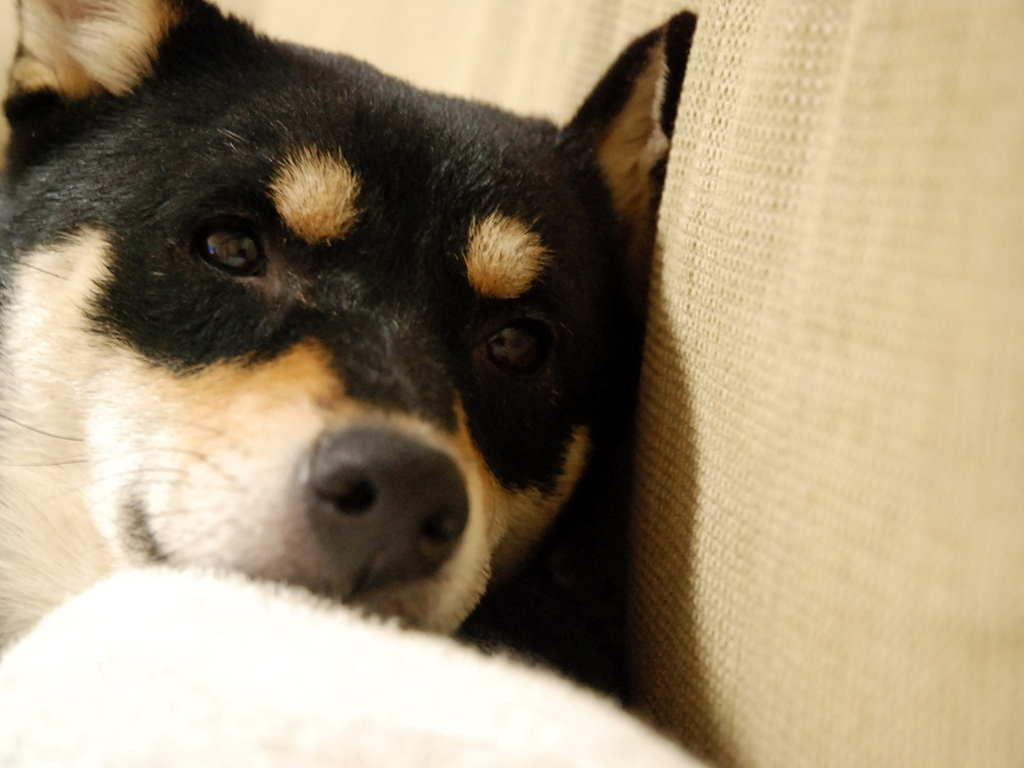What is the breed of the dog in the image? The dog in the image appears to be a Shiba Inu, a breed known for its fox-like features, alert expression, and compact size. 